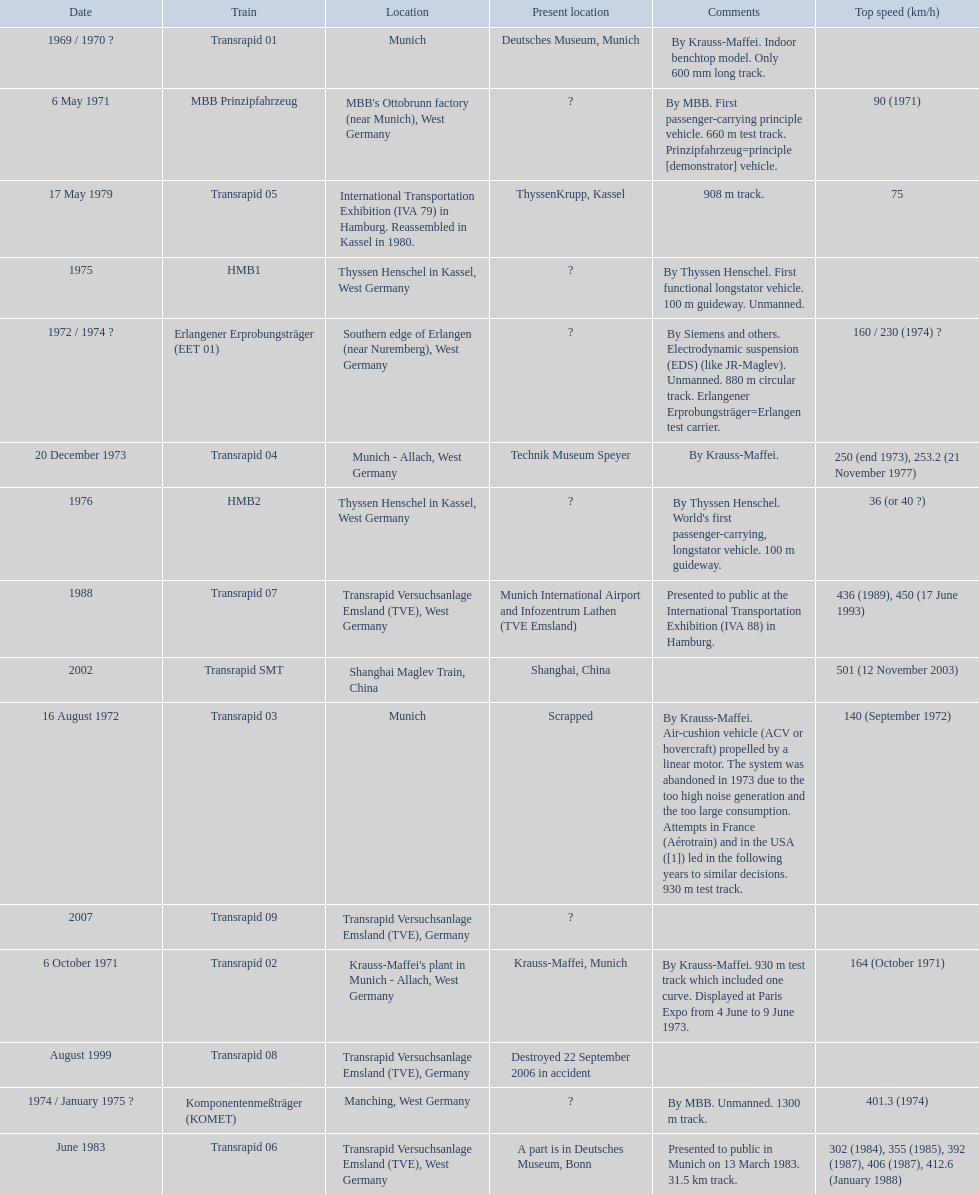How many trains other than the transrapid 07 can go faster than 450km/h? 1. 